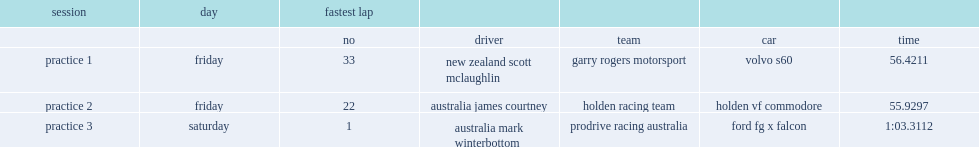List the fastest time that mclaughlin set in 2016 perth supersprint? 56.4211. 